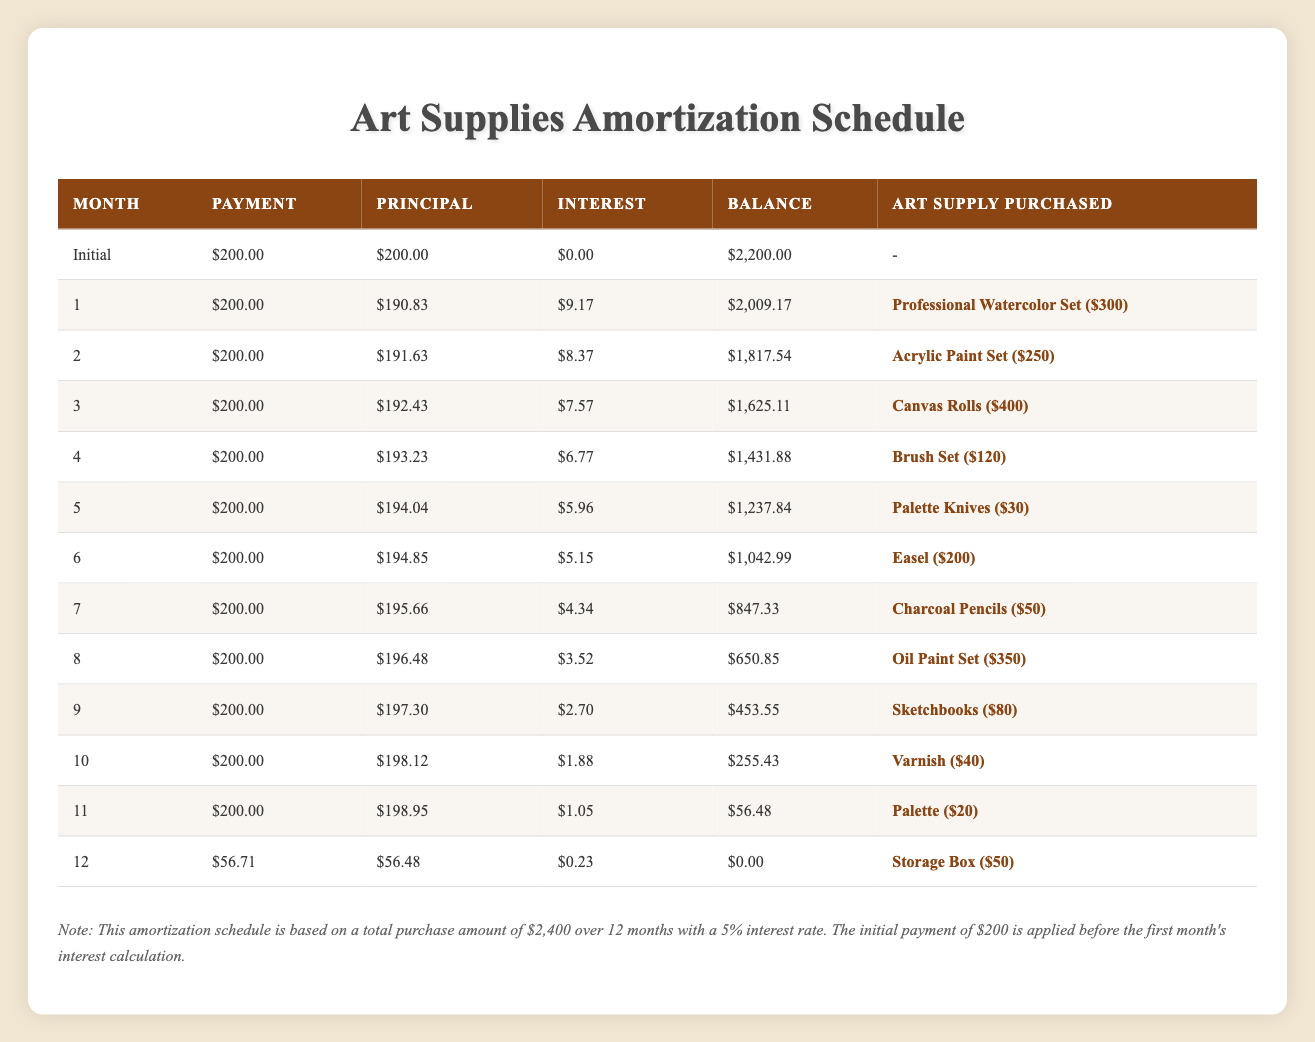What is the total cost of the Professional Watercolor Set? The table directly provides the cost of each item purchased, and for the Professional Watercolor Set, the cost is mentioned as $300 in the corresponding month.
Answer: $300 In which month was the Easel purchased? The month of purchase for each item is listed in the table, and for the Easel, it shows it was purchased in month six.
Answer: Month 6 What is the total principal paid over the 12 months? To find the total principal paid over 12 months, add up all the principal amounts from each month's row in the table. The principal paid for each month can be summarized as follows: (200 + 190.83 + 191.63 + ... + 56.48) = 2,320.00. The detailed calculation requires summing the values from the "Principal" column for each month including the initial payment.
Answer: $2,320.00 Was there a payment made that included interest higher than $9 in any month? Each month shows an interest component in the table, and the only month with an interest amount greater than $9 appears when we check the values. From the values given, none of the months after the first month had interest higher than $9, as they decline steadily.
Answer: No What was the average monthly payment throughout the payment term? The average monthly payment can be determined by adding up the total payments made and dividing by the number of months. Total payments: (200 + 200 + 200 + ... + 56.71) totals to $2,400 paid over 12 months, so the average is $2,400 / 12 = $200.
Answer: $200 How much was paid in interest for the month with the highest interest? From the table, we identify that the first month (month 1) had the highest interest charge of $9.17. Since it is the only value higher than the rest, it indicates that month one had the most significant interest payment.
Answer: $9.17 Did the total amount of interest paid exceed $20 at any point? We need to add all the interest amounts from each month which are provided in the table. Summing up all interests gives us: (0 + 9.17 + 8.37 + ... + 0.23) = $37.75, thus confirming that it did exceed $20.
Answer: Yes In months 11 and 12, which item had the lowest cost from the purchases? From the table in months 11 and 12, the items purchased were Palette ($20) and Storage Box ($50). Comparing the two, the Palette's cost is lower.
Answer: Palette ($20) How much was remaining in the balance after the last payment? According to the table, after the last payment (in month 12), the balance is noted to be $0.00. The final row shows the balance reaching zero after all payments were made, concluding the purchasing obligation.
Answer: $0.00 